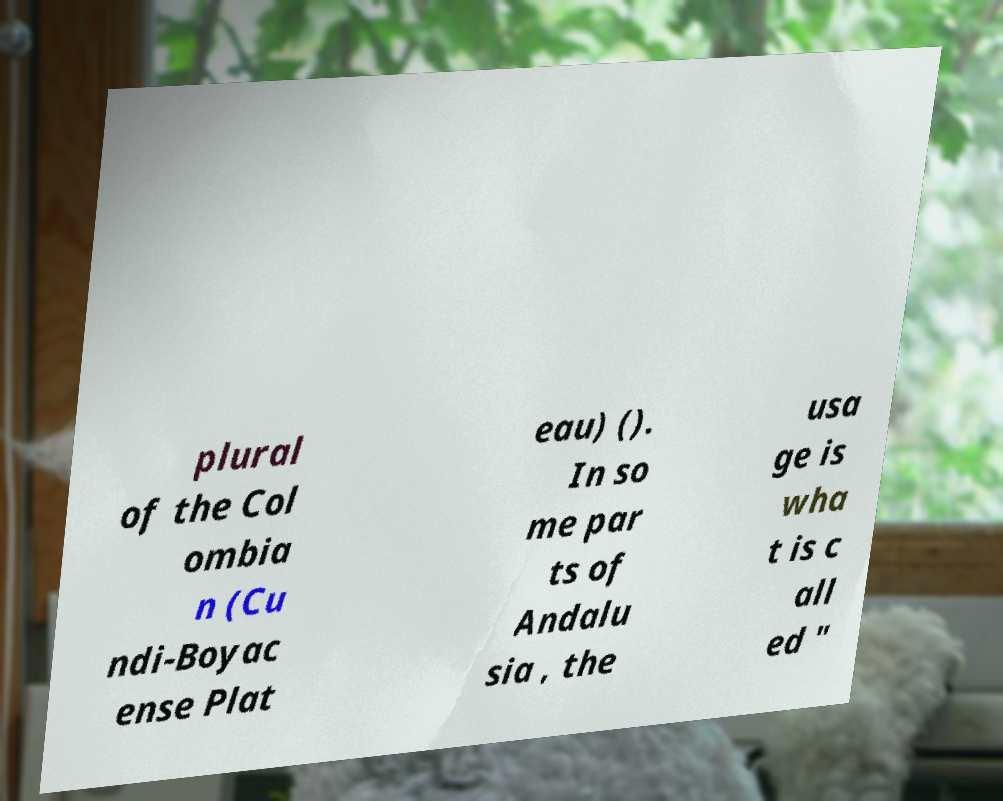Could you extract and type out the text from this image? plural of the Col ombia n (Cu ndi-Boyac ense Plat eau) (). In so me par ts of Andalu sia , the usa ge is wha t is c all ed " 